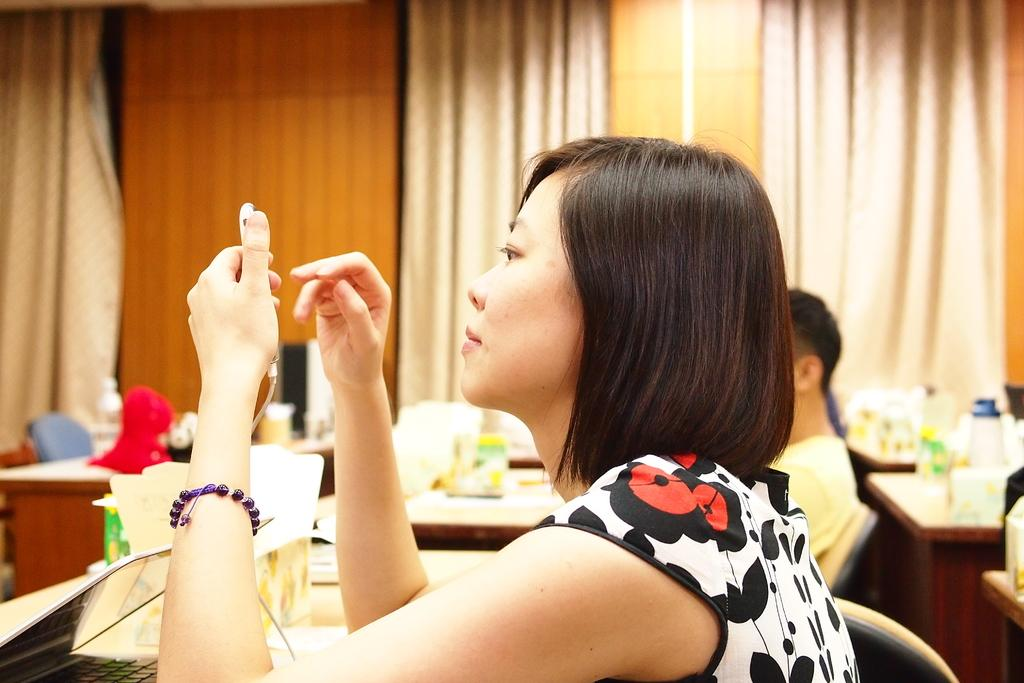How many people are in the image? There are two persons in the image. What electronic device can be seen in the image? There is a laptop in the image. What type of furniture is present in the image? There are tables and chairs in the image. What is on top of the tables? There are objects on the tables. What is visible on the wall in the image? There is a wall in the image. What type of window treatment is present in the image? There are curtains in the image. What type of sponge is being used by one of the persons in the image? There is no sponge visible in the image. What type of locket is being worn by one of the persons in the image? There is no locket visible in the image. 